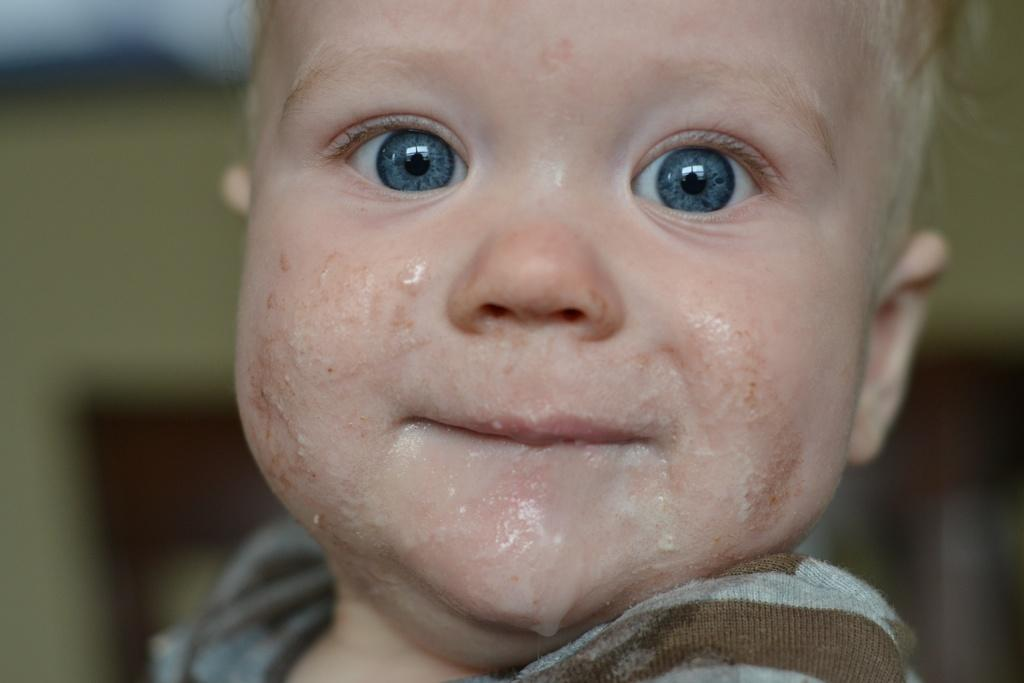What is the main subject of the picture? The main subject of the picture is an infant. What is the infant doing in the picture? The infant is sitting in the picture. What is the infant wearing? The infant is wearing a shirt. Can you describe the infant's physical appearance? The infant has white hair and blue eyes. What is the color of the background in the picture? The background has a yellow color shade. What thought is the infant having while singing a line from a song in the image? There is no indication in the image that the infant is thinking, singing, or reciting a line from a song. 